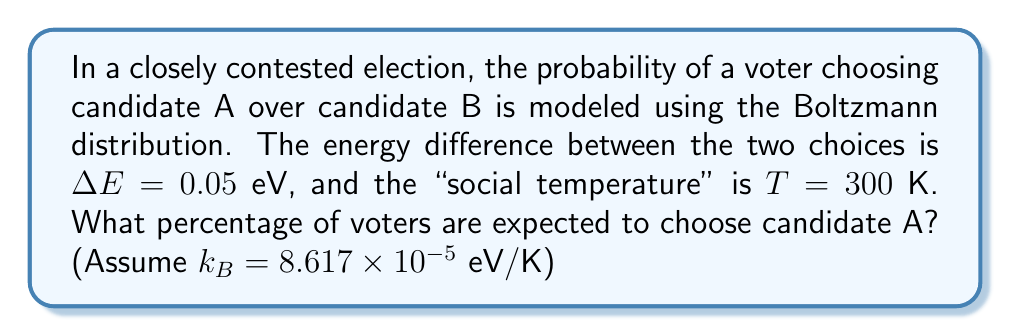Teach me how to tackle this problem. To solve this problem, we'll use the Boltzmann distribution and follow these steps:

1) The Boltzmann distribution gives the probability of a system being in a state with energy $E_i$:

   $P_i = \frac{e^{-E_i/k_BT}}{\sum_j e^{-E_j/k_BT}}$

2) In our case, we have two states (candidate A and B), and we're given the energy difference $\Delta E$. Let's set the energy of choosing candidate B as our reference point ($E_B = 0$) and the energy of choosing candidate A as $E_A = \Delta E = 0.05$ eV.

3) The probability of choosing candidate A is:

   $P_A = \frac{e^{-E_A/k_BT}}{e^{-E_A/k_BT} + e^{-E_B/k_BT}}$

4) Substituting the values:

   $P_A = \frac{e^{-0.05/(8.617 \times 10^{-5} \times 300)}}{e^{-0.05/(8.617 \times 10^{-5} \times 300)} + e^{0}}$

5) Simplify the exponent:

   $P_A = \frac{e^{-1.9373}}{e^{-1.9373} + 1}$

6) Calculate:

   $P_A = \frac{0.1442}{0.1442 + 1} = 0.1260$

7) Convert to percentage:

   $P_A = 0.1260 \times 100\% = 12.60\%$

Therefore, 12.60% of voters are expected to choose candidate A.
Answer: 12.60% 